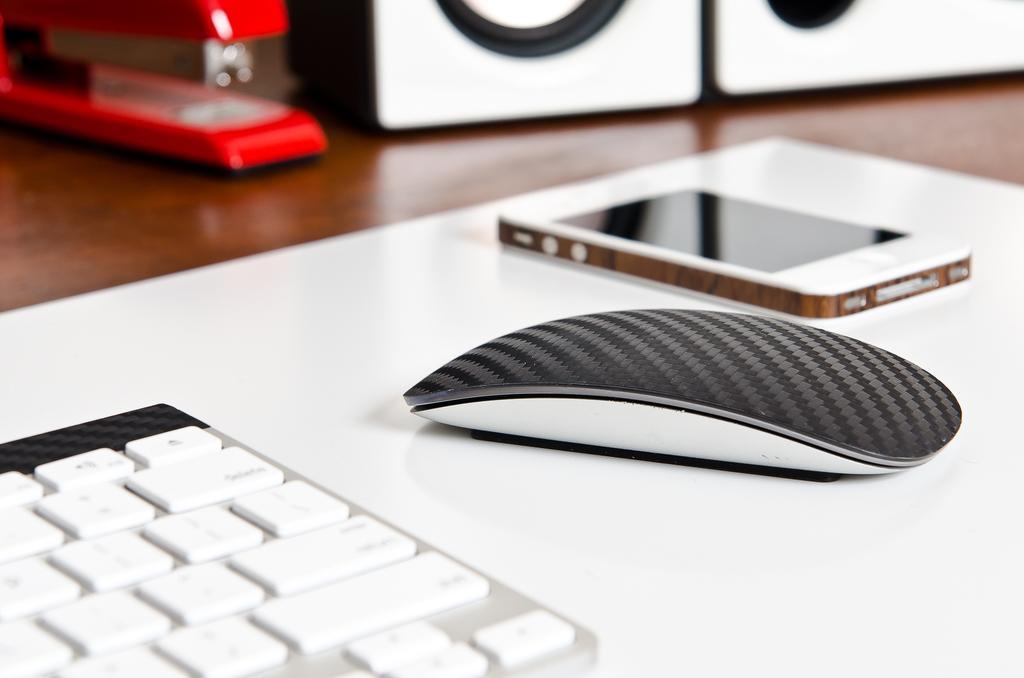Can you describe this image briefly? In this picture we can see a mobile, mouse, keyboard, speakers, stapler and these all are placed on a platform. 